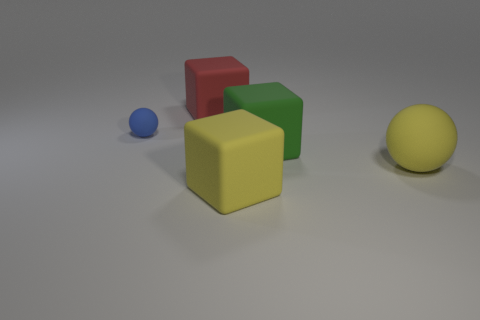What number of shiny things are either green things or balls?
Keep it short and to the point. 0. What is the size of the other rubber object that is the same shape as the tiny blue matte thing?
Your response must be concise. Large. Are there any other things that are the same size as the yellow rubber sphere?
Your answer should be compact. Yes. Do the green block and the yellow rubber object on the left side of the large rubber ball have the same size?
Your answer should be very brief. Yes. What is the shape of the object that is behind the tiny blue ball?
Offer a terse response. Cube. There is a large rubber cube that is in front of the rubber ball that is on the right side of the tiny object; what is its color?
Ensure brevity in your answer.  Yellow. What color is the other thing that is the same shape as the blue matte thing?
Keep it short and to the point. Yellow. How many rubber objects are the same color as the big sphere?
Ensure brevity in your answer.  1. There is a tiny rubber sphere; is it the same color as the block behind the blue thing?
Keep it short and to the point. No. What shape is the matte object that is in front of the small matte object and on the left side of the big green object?
Keep it short and to the point. Cube. 